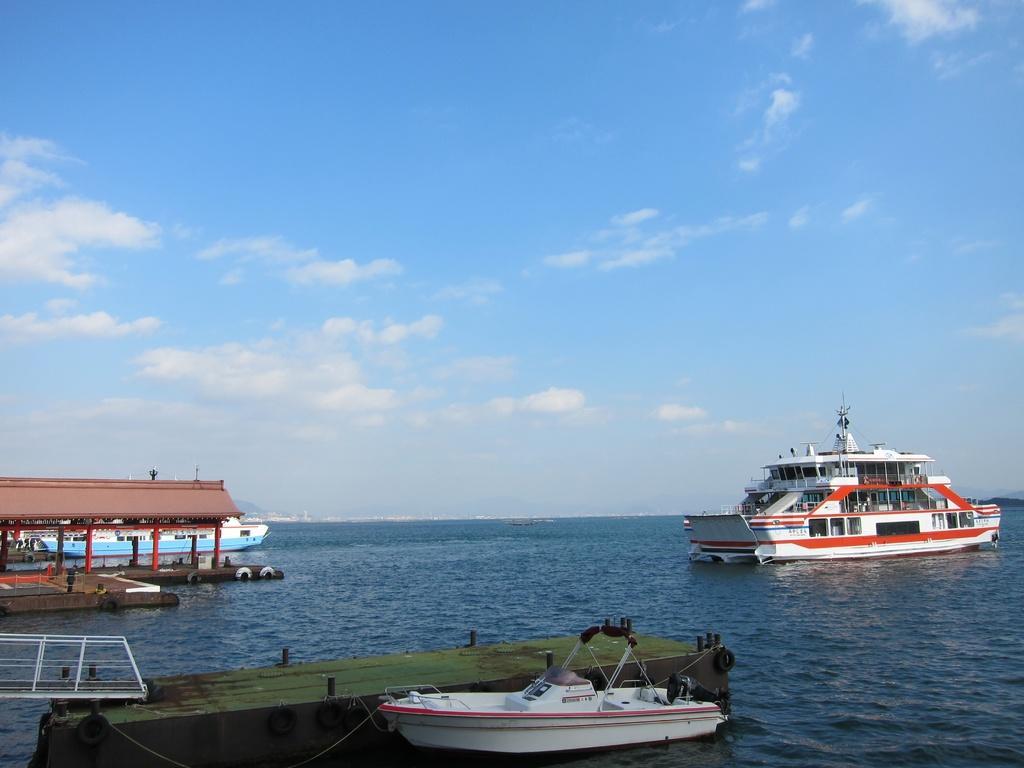Could you give a brief overview of what you see in this image? In this image I can see water and on it I can see number of boats. I can also see a platform on the bottom side of this image and in the centre I can see a shed. In the background I can see clouds and the sky. 